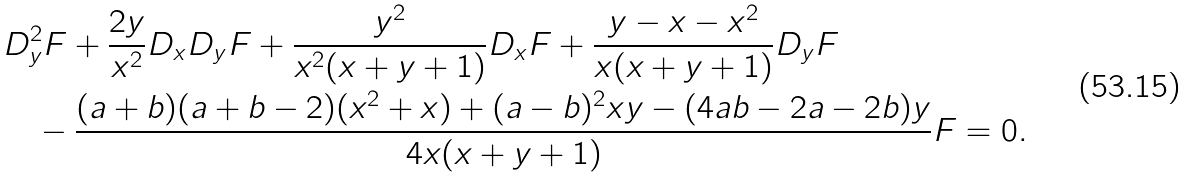<formula> <loc_0><loc_0><loc_500><loc_500>& D _ { y } ^ { 2 } F + \frac { 2 y } { x ^ { 2 } } D _ { x } D _ { y } F + \frac { y ^ { 2 } } { x ^ { 2 } ( x + y + 1 ) } D _ { x } F + \frac { y - x - x ^ { 2 } } { x ( x + y + 1 ) } D _ { y } F \\ & \quad - \frac { ( a + b ) ( a + b - 2 ) ( x ^ { 2 } + x ) + ( a - b ) ^ { 2 } x y - ( 4 a b - 2 a - 2 b ) y } { 4 x ( x + y + 1 ) } F = 0 .</formula> 